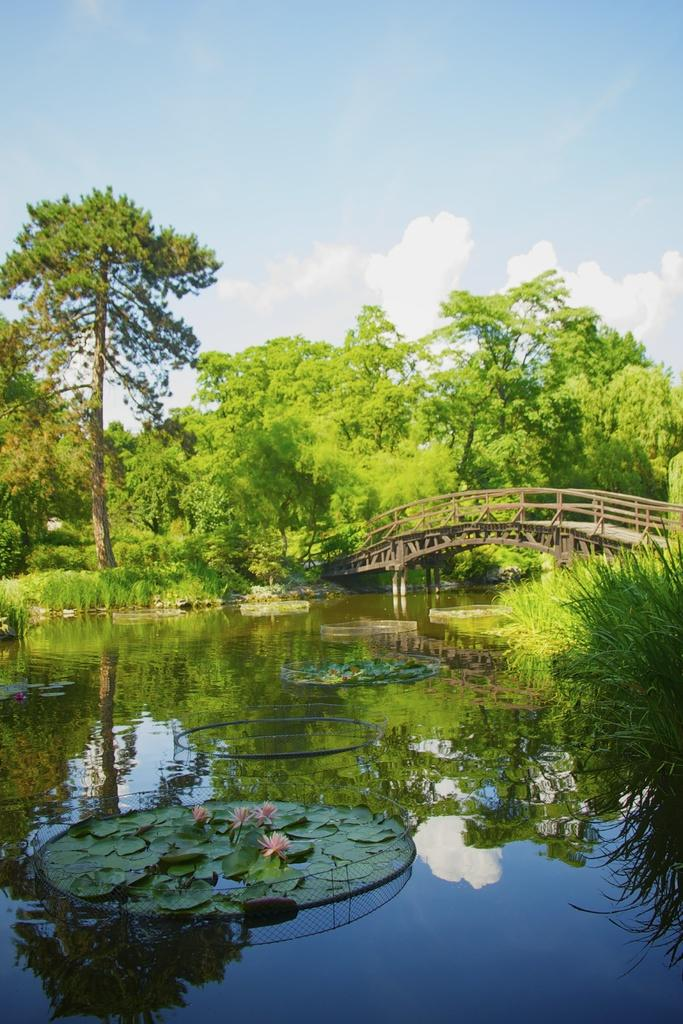What is the primary element present in the image? There is water in the image. What can be found floating on the water? There are lotus leaves and lotus flowers in the water. Is there any man-made structure visible in the image? Yes, there is a bridge in the image. What type of vegetation is present in the image? There are trees in the image. How would you describe the weather based on the image? The sky is cloudy in the image. What type of engine is visible in the image? There is no engine present in the image. What kind of lunch is being prepared on the lotus leaves in the image? There is no lunch preparation or any food items visible on the lotus leaves in the image. 